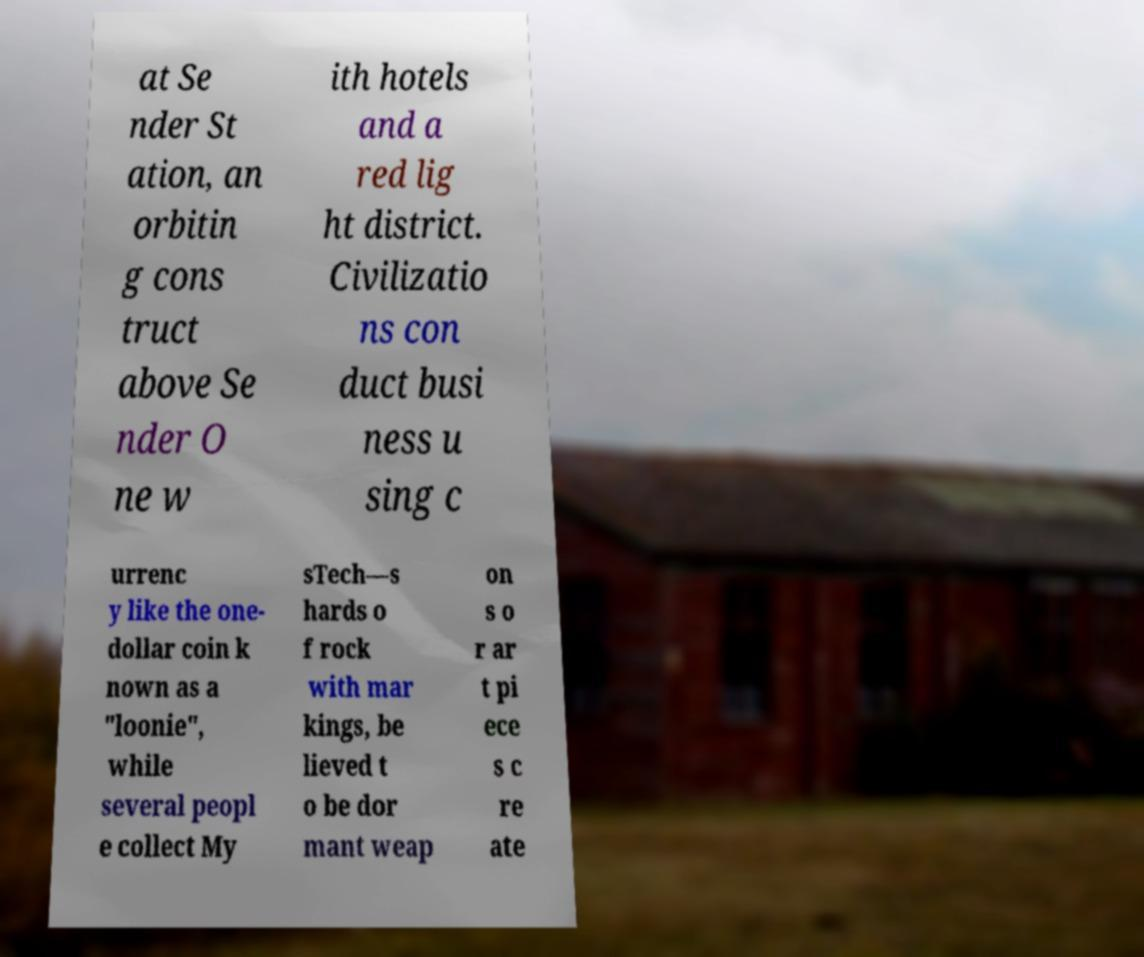Could you assist in decoding the text presented in this image and type it out clearly? at Se nder St ation, an orbitin g cons truct above Se nder O ne w ith hotels and a red lig ht district. Civilizatio ns con duct busi ness u sing c urrenc y like the one- dollar coin k nown as a "loonie", while several peopl e collect My sTech—s hards o f rock with mar kings, be lieved t o be dor mant weap on s o r ar t pi ece s c re ate 